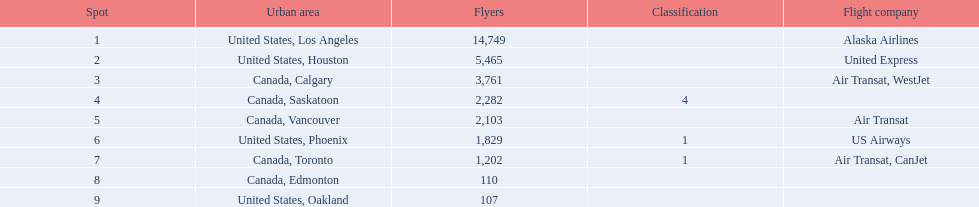What are the cities that are associated with the playa de oro international airport? United States, Los Angeles, United States, Houston, Canada, Calgary, Canada, Saskatoon, Canada, Vancouver, United States, Phoenix, Canada, Toronto, Canada, Edmonton, United States, Oakland. What is uniteed states, los angeles passenger count? 14,749. What other cities passenger count would lead to 19,000 roughly when combined with previous los angeles? Canada, Calgary. 